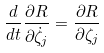<formula> <loc_0><loc_0><loc_500><loc_500>\frac { d } { d t } \frac { \partial R } { \partial \dot { \zeta } _ { j } } = \frac { \partial R } { \partial \zeta _ { j } }</formula> 